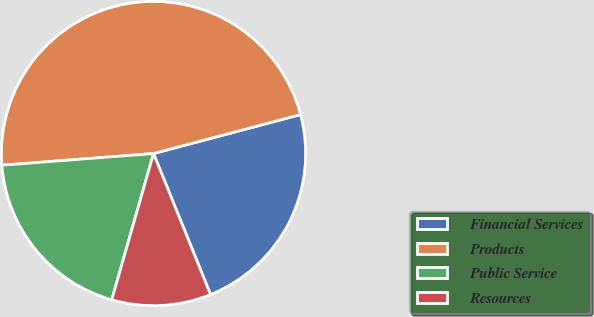Convert chart. <chart><loc_0><loc_0><loc_500><loc_500><pie_chart><fcel>Financial Services<fcel>Products<fcel>Public Service<fcel>Resources<nl><fcel>23.01%<fcel>47.1%<fcel>19.35%<fcel>10.54%<nl></chart> 